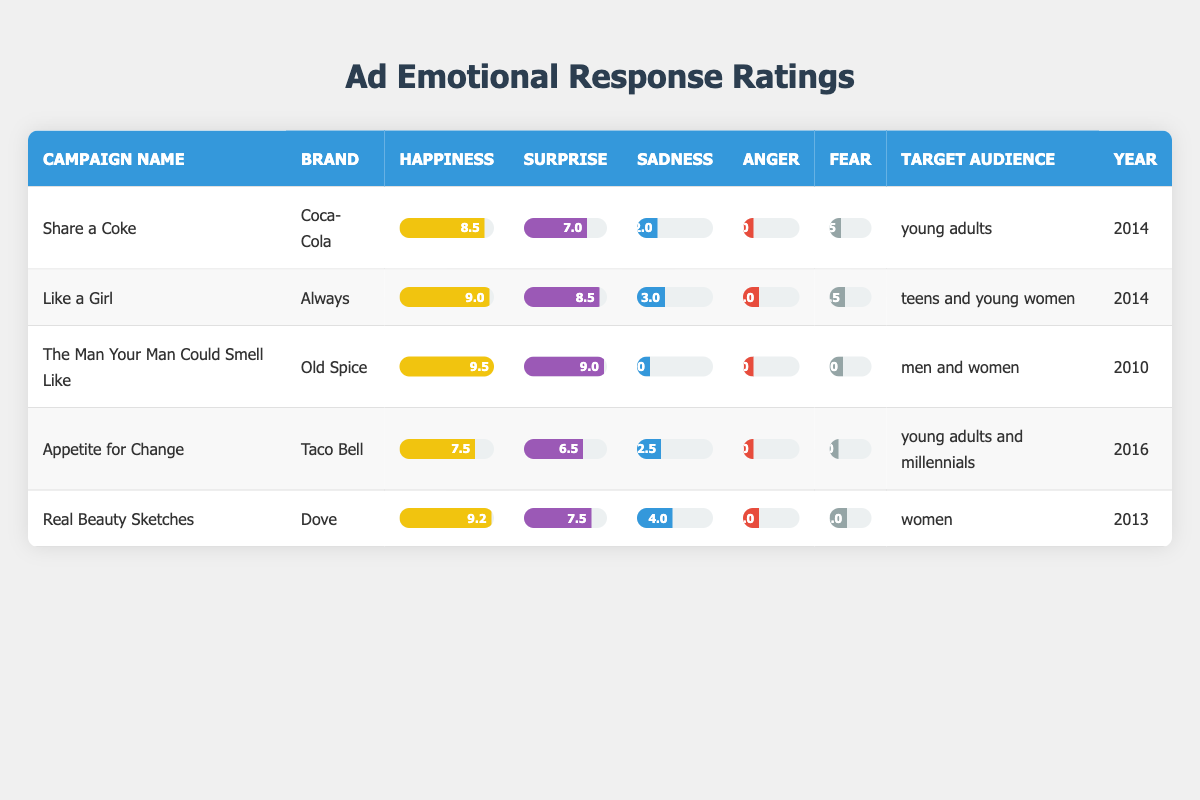What was the happiest emotional response rating for the "Like a Girl" campaign? The "Like a Girl" campaign had a happiness rating of 9.0, as per the emotional response ratings provided in the table.
Answer: 9.0 Which brand had the lowest anger rating in their advertising campaign? In the table, both the "Share a Coke" and "The Man Your Man Could Smell Like" campaigns had the lowest anger rating of 1.0.
Answer: 1.0 What is the difference in the happiness ratings between "Real Beauty Sketches" and "Appetite for Change"? "Real Beauty Sketches" has a happiness rating of 9.2 and "Appetite for Change" has 7.5; subtracting these gives 9.2 - 7.5 = 1.7.
Answer: 1.7 Did any campaign in the year 2014 achieve a surprise rating of at least 8.0? Yes, both the "Share a Coke" campaign and "Like a Girl" campaign, which were released in 2014, achieved surprise ratings of 7.0 and 8.5 respectively, with "Like a Girl" exceeding the threshold.
Answer: Yes What is the average sadness rating across all campaigns? To find the average sadness rating, I sum the sadness ratings from all five campaigns: (2.0 + 3.0 + 1.0 + 2.5 + 4.0) = 12.5. Dividing by the number of campaigns gives an average of 12.5/5 = 2.5.
Answer: 2.5 Which campaign had the highest surprise rating, and what was it? The "The Man Your Man Could Smell Like" campaign had the highest surprise rating of 9.0, which is the highest among all campaigns listed in the table.
Answer: 9.0 Is it true that the "Appetite for Change" campaign received a higher fear rating than the "Like a Girl" campaign? No, the "Appetite for Change" campaign had a fear rating of 1.0, while the "Like a Girl" campaign had a fear rating of 2.5, making this statement false.
Answer: No Which target audience had the lowest rating for sadness across all campaigns? The "Share a Coke" campaign had the lowest sadness rating of 2.0 targeting young adults, which is the least among all campaigns listed for sadness.
Answer: Young adults 